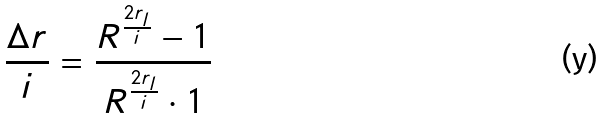<formula> <loc_0><loc_0><loc_500><loc_500>\frac { \Delta r } { i } = \frac { R ^ { \frac { 2 r _ { l } } { i } } - 1 } { R ^ { \frac { 2 r _ { l } } { i } } \cdot 1 }</formula> 